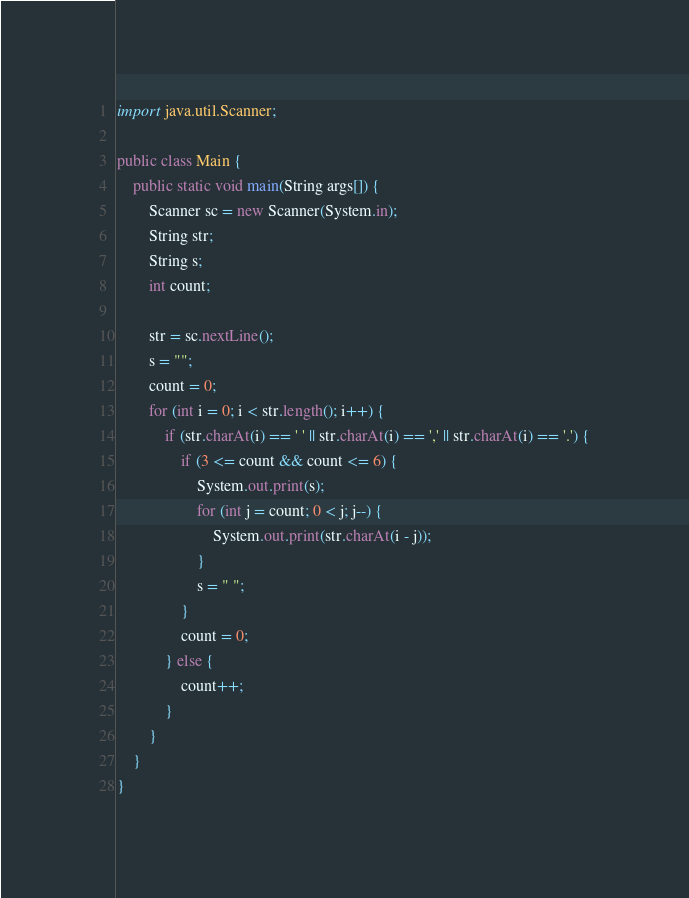<code> <loc_0><loc_0><loc_500><loc_500><_Java_>import java.util.Scanner;

public class Main {
	public static void main(String args[]) {
		Scanner sc = new Scanner(System.in);
		String str;
		String s;
		int count;

		str = sc.nextLine();
		s = "";
		count = 0;
		for (int i = 0; i < str.length(); i++) {
			if (str.charAt(i) == ' ' || str.charAt(i) == ',' || str.charAt(i) == '.') {
				if (3 <= count && count <= 6) {
					System.out.print(s);
					for (int j = count; 0 < j; j--) {
						System.out.print(str.charAt(i - j));
					}
					s = " ";
				}
				count = 0;
			} else {
				count++;
			}
		}
	}
}</code> 